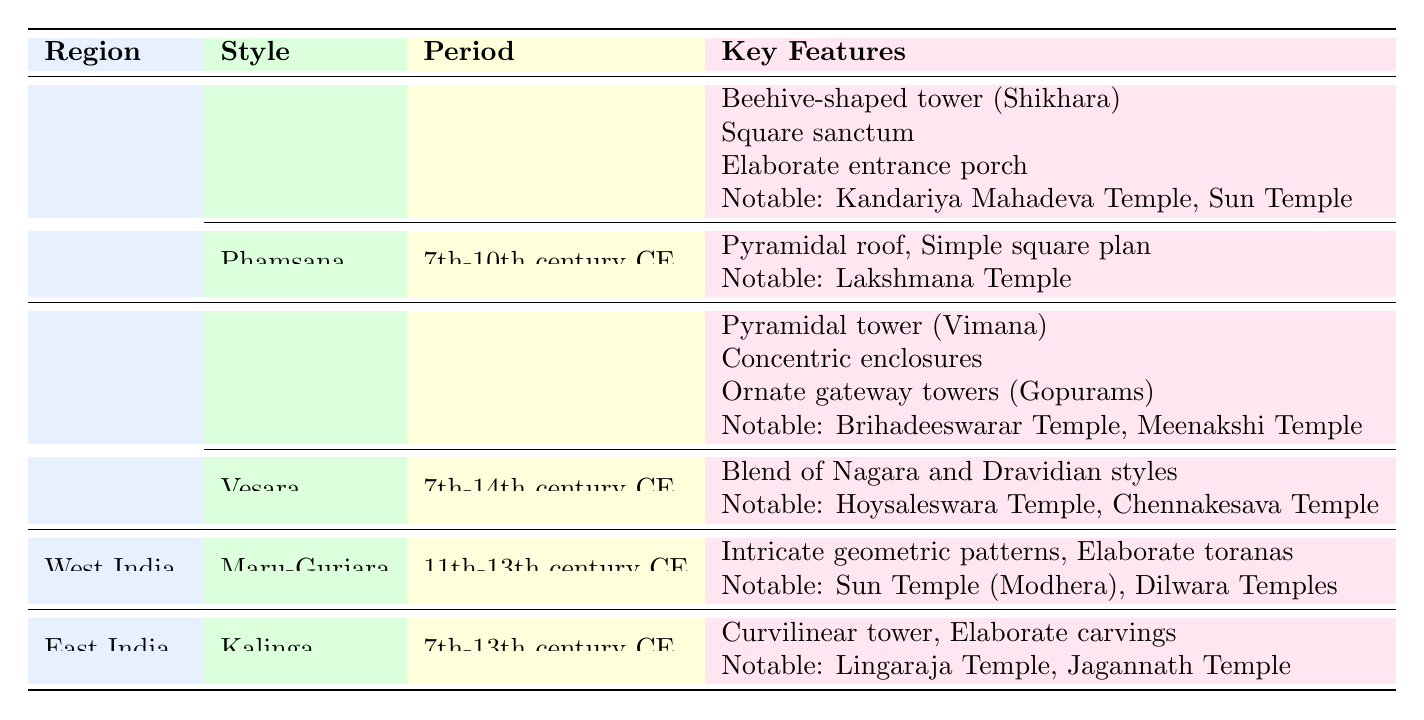What are the notable examples of the Nagara style in North India? In the table under North India, the Nagara style lists two notable examples: Kandariya Mahadeva Temple located in Khajuraho and Sun Temple located in Konark.
Answer: Kandariya Mahadeva Temple, Sun Temple What is the period of the Dravidian style of architecture? The table specifies that the Dravidian style spans from the 7th to the 18th century CE.
Answer: 7th-18th century CE How many temple architectural styles are listed for West India? The table shows one architectural style, Maru-Gurjara, listed under West India.
Answer: One style Which region features the Kalinga style? The table indicates that the Kalinga style is found in East India.
Answer: East India Are there any key features shared between the Dravidian and Vesara styles? Reviewing the key features in the table, both styles include architectural components that showcase intricate designs, although they are specific to each style. Thus, the answer is no.
Answer: No How many notable examples are listed for the Vesara style? The Vesara style in South India has two notable examples listed: Hoysaleswara Temple and Chennakesava Temple.
Answer: Two examples Which architectural style features a pyramidal roof with a simple square plan, and where is it located? The table lists the Phamsana style with a pyramidal roof and simple square plan under North India, specifically noting Lakshmana Temple as an example.
Answer: Phamsana Did the Kalinga style thrive in a period earlier than that of the Nagara style? The Kalinga style is from the 7th to the 13th century CE, while the Nagara style spans from the 5th to the 13th century CE. Hence, the Kalinga style did not thrive earlier.
Answer: No What is the primary characteristic of the Maru-Gurjara style, and how does it differ from the Dravidian style? The Maru-Gurjara style is characterized by intricate geometric patterns and elaborate toranas, differing significantly from the Dravidian style, which features pyramidal towers and concentric enclosures.
Answer: Intricate geometric patterns Which temple is an example of the Dravidian style, and which dynasty is it associated with? The Brihadeeswarar Temple is an example of the Dravidian style located in Thanjavur, associated with the Chola dynasty.
Answer: Brihadeeswarar Temple, Chola dynasty 